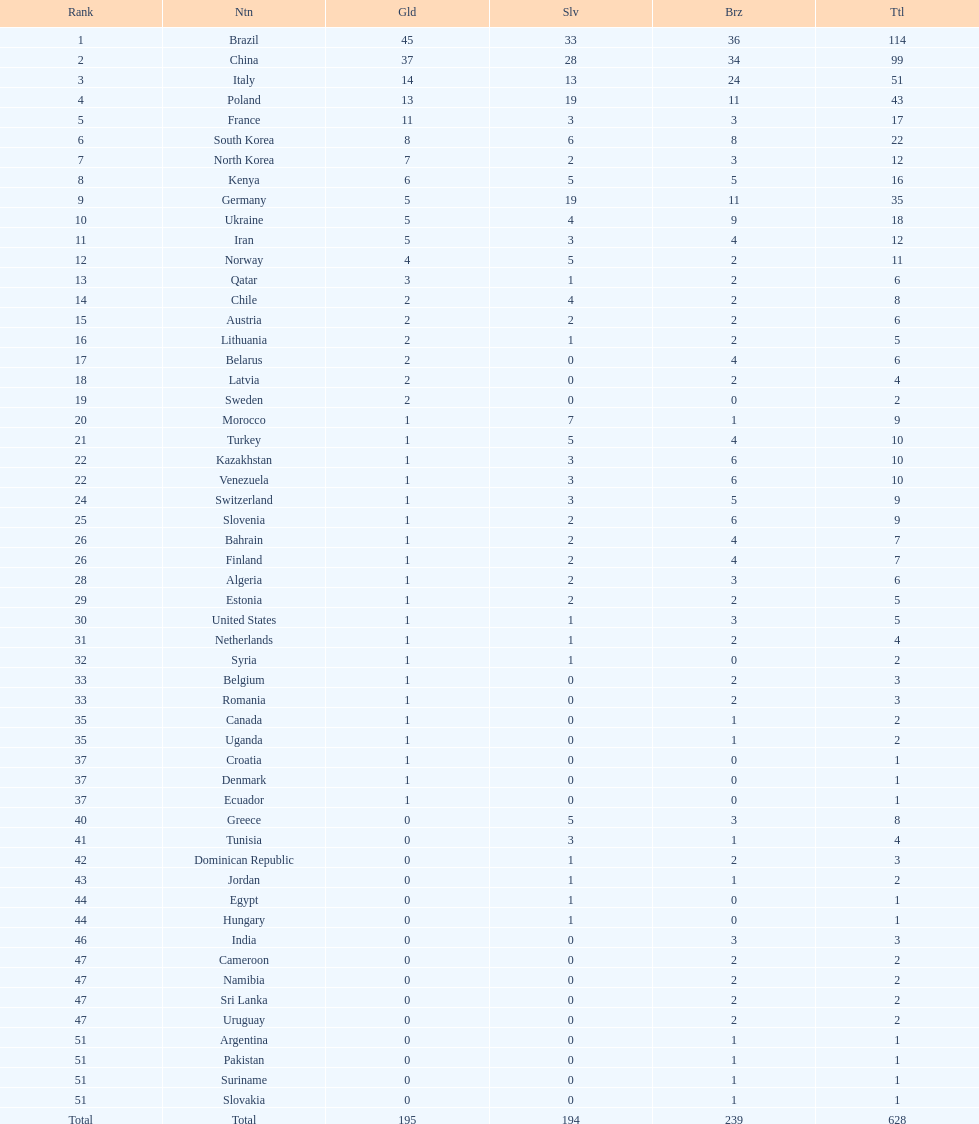Could you help me parse every detail presented in this table? {'header': ['Rank', 'Ntn', 'Gld', 'Slv', 'Brz', 'Ttl'], 'rows': [['1', 'Brazil', '45', '33', '36', '114'], ['2', 'China', '37', '28', '34', '99'], ['3', 'Italy', '14', '13', '24', '51'], ['4', 'Poland', '13', '19', '11', '43'], ['5', 'France', '11', '3', '3', '17'], ['6', 'South Korea', '8', '6', '8', '22'], ['7', 'North Korea', '7', '2', '3', '12'], ['8', 'Kenya', '6', '5', '5', '16'], ['9', 'Germany', '5', '19', '11', '35'], ['10', 'Ukraine', '5', '4', '9', '18'], ['11', 'Iran', '5', '3', '4', '12'], ['12', 'Norway', '4', '5', '2', '11'], ['13', 'Qatar', '3', '1', '2', '6'], ['14', 'Chile', '2', '4', '2', '8'], ['15', 'Austria', '2', '2', '2', '6'], ['16', 'Lithuania', '2', '1', '2', '5'], ['17', 'Belarus', '2', '0', '4', '6'], ['18', 'Latvia', '2', '0', '2', '4'], ['19', 'Sweden', '2', '0', '0', '2'], ['20', 'Morocco', '1', '7', '1', '9'], ['21', 'Turkey', '1', '5', '4', '10'], ['22', 'Kazakhstan', '1', '3', '6', '10'], ['22', 'Venezuela', '1', '3', '6', '10'], ['24', 'Switzerland', '1', '3', '5', '9'], ['25', 'Slovenia', '1', '2', '6', '9'], ['26', 'Bahrain', '1', '2', '4', '7'], ['26', 'Finland', '1', '2', '4', '7'], ['28', 'Algeria', '1', '2', '3', '6'], ['29', 'Estonia', '1', '2', '2', '5'], ['30', 'United States', '1', '1', '3', '5'], ['31', 'Netherlands', '1', '1', '2', '4'], ['32', 'Syria', '1', '1', '0', '2'], ['33', 'Belgium', '1', '0', '2', '3'], ['33', 'Romania', '1', '0', '2', '3'], ['35', 'Canada', '1', '0', '1', '2'], ['35', 'Uganda', '1', '0', '1', '2'], ['37', 'Croatia', '1', '0', '0', '1'], ['37', 'Denmark', '1', '0', '0', '1'], ['37', 'Ecuador', '1', '0', '0', '1'], ['40', 'Greece', '0', '5', '3', '8'], ['41', 'Tunisia', '0', '3', '1', '4'], ['42', 'Dominican Republic', '0', '1', '2', '3'], ['43', 'Jordan', '0', '1', '1', '2'], ['44', 'Egypt', '0', '1', '0', '1'], ['44', 'Hungary', '0', '1', '0', '1'], ['46', 'India', '0', '0', '3', '3'], ['47', 'Cameroon', '0', '0', '2', '2'], ['47', 'Namibia', '0', '0', '2', '2'], ['47', 'Sri Lanka', '0', '0', '2', '2'], ['47', 'Uruguay', '0', '0', '2', '2'], ['51', 'Argentina', '0', '0', '1', '1'], ['51', 'Pakistan', '0', '0', '1', '1'], ['51', 'Suriname', '0', '0', '1', '1'], ['51', 'Slovakia', '0', '0', '1', '1'], ['Total', 'Total', '195', '194', '239', '628']]} How many additional medals does south korea have compared to north korea? 10. 